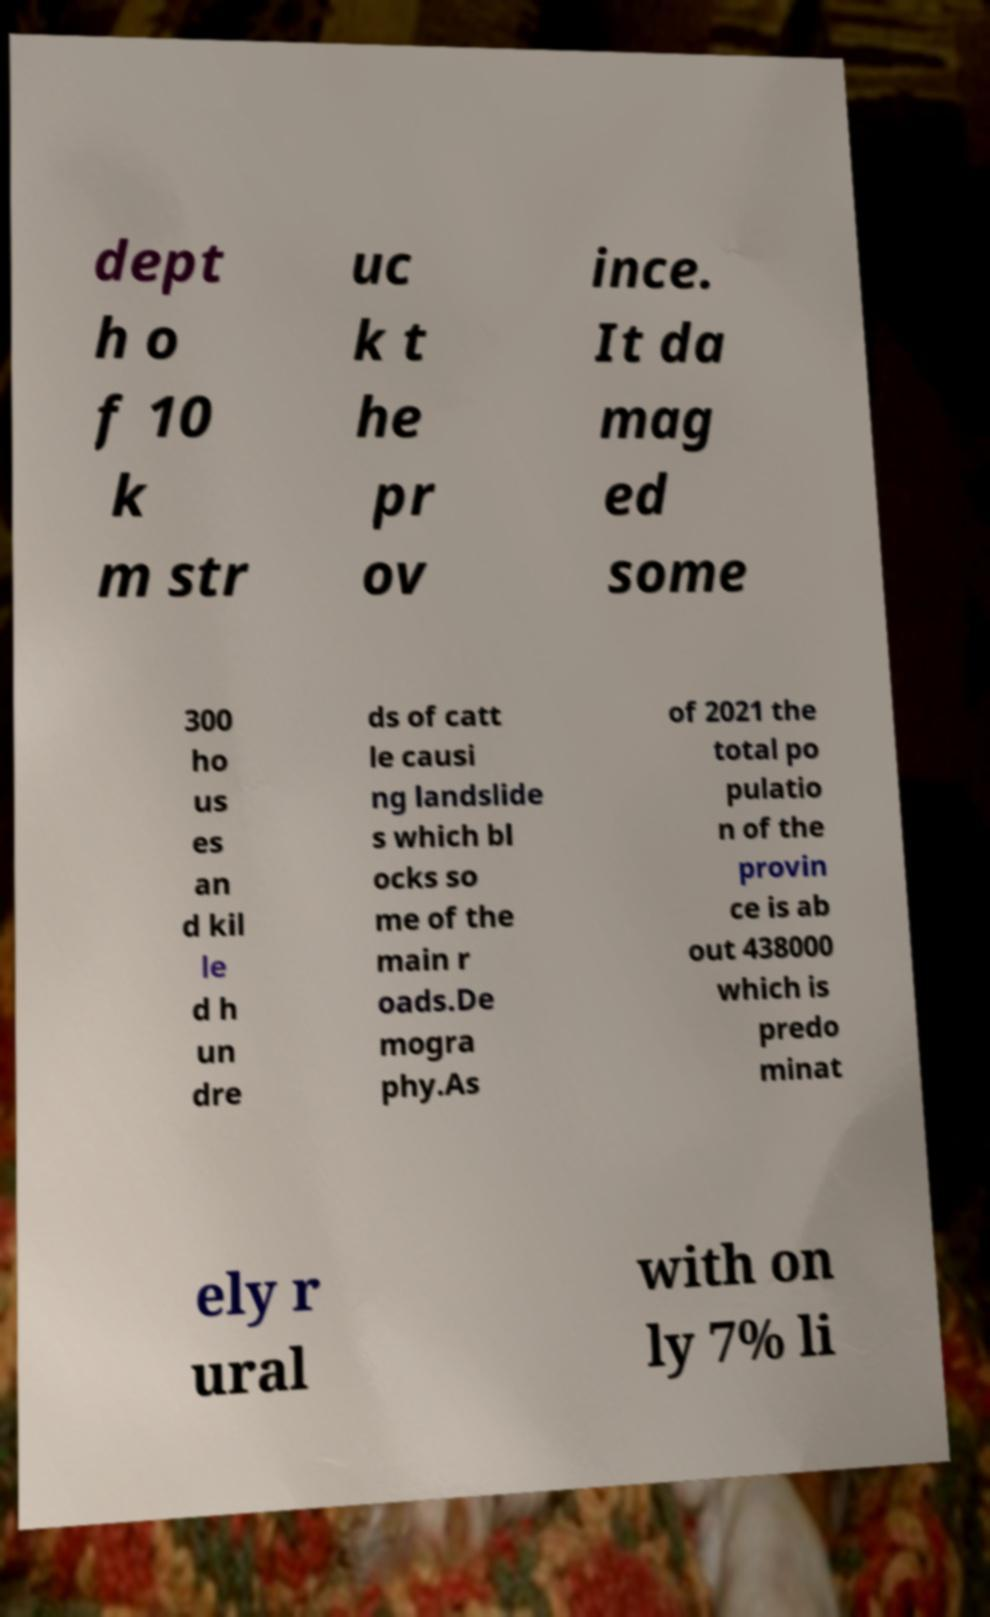Could you extract and type out the text from this image? dept h o f 10 k m str uc k t he pr ov ince. It da mag ed some 300 ho us es an d kil le d h un dre ds of catt le causi ng landslide s which bl ocks so me of the main r oads.De mogra phy.As of 2021 the total po pulatio n of the provin ce is ab out 438000 which is predo minat ely r ural with on ly 7% li 